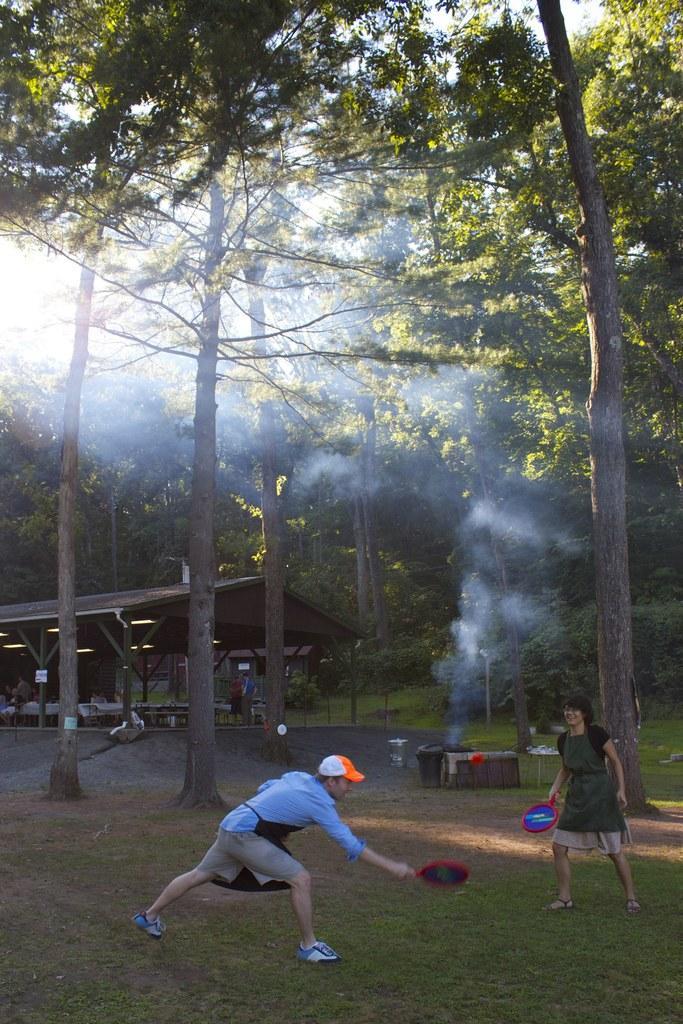Please provide a concise description of this image. In this image I can see grass ground and on it I can see two people are standing. I can also see see both of them are holding few things and here I can see one of them is wearing a cap. In the background I can see smoke, number of trees and few other things. 